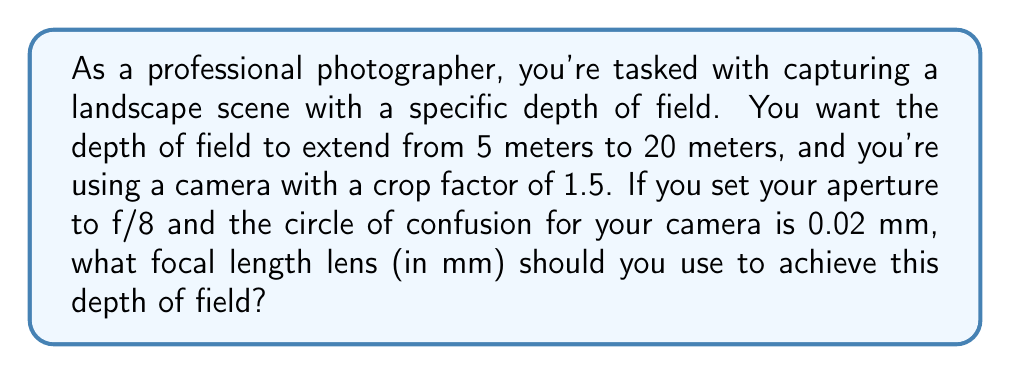Teach me how to tackle this problem. To solve this problem, we'll use the depth of field equation and the thin lens formula. Let's break it down step by step:

1) First, we need to calculate the hyperfocal distance (H) using the formula:
   $$H = \frac{f^2}{N \cdot c} + f$$
   where f is the focal length, N is the f-number (aperture), and c is the circle of confusion.

2) We also know that for the near limit of depth of field (Dn):
   $$D_n = \frac{H \cdot s}{H + (s - f)}$$
   where s is the focus distance.

3) And for the far limit of depth of field (Df):
   $$D_f = \frac{H \cdot s}{H - (s - f)}$$

4) We're given that Dn = 5 m and Df = 20 m. We need to find s and H.

5) From the thin lens formula, we know:
   $$\frac{1}{s} = \frac{1}{D_n} + \frac{1}{D_f}$$

6) Substituting our values:
   $$\frac{1}{s} = \frac{1}{5} + \frac{1}{20} = \frac{5}{20} = \frac{1}{4}$$
   So, s = 4 m

7) Now we can use the equation for Dn to find H:
   $$5 = \frac{H \cdot 4}{H + (4 - f)}$$

8) Simplifying:
   $$5H + 5(4-f) = 4H$$
   $$H = 20 - 5f$$

9) Substituting this into our original hyperfocal distance equation:
   $$20 - 5f = \frac{f^2}{8 \cdot 0.02} + f$$

10) Simplifying:
    $$20 - 5f = \frac{f^2}{0.16} + f$$
    $$3.2 - 0.8f = 0.16f^2 + 0.16f$$
    $$0.16f^2 + 0.96f - 3.2 = 0$$

11) This is a quadratic equation. Solving it:
    $$f = \frac{-0.96 \pm \sqrt{0.96^2 + 4(0.16)(3.2)}}{2(0.16)}$$
    $$f \approx 16.67 \text{ or } -22.67$$

12) The negative solution doesn't make sense for a focal length, so f ≈ 16.67 mm.

13) However, remember that we need to account for the crop factor of 1.5:
    $$16.67 \cdot 1.5 = 25 \text{ mm}$$

Therefore, the focal length needed is approximately 25 mm.
Answer: The focal length lens you should use is approximately 25 mm. 